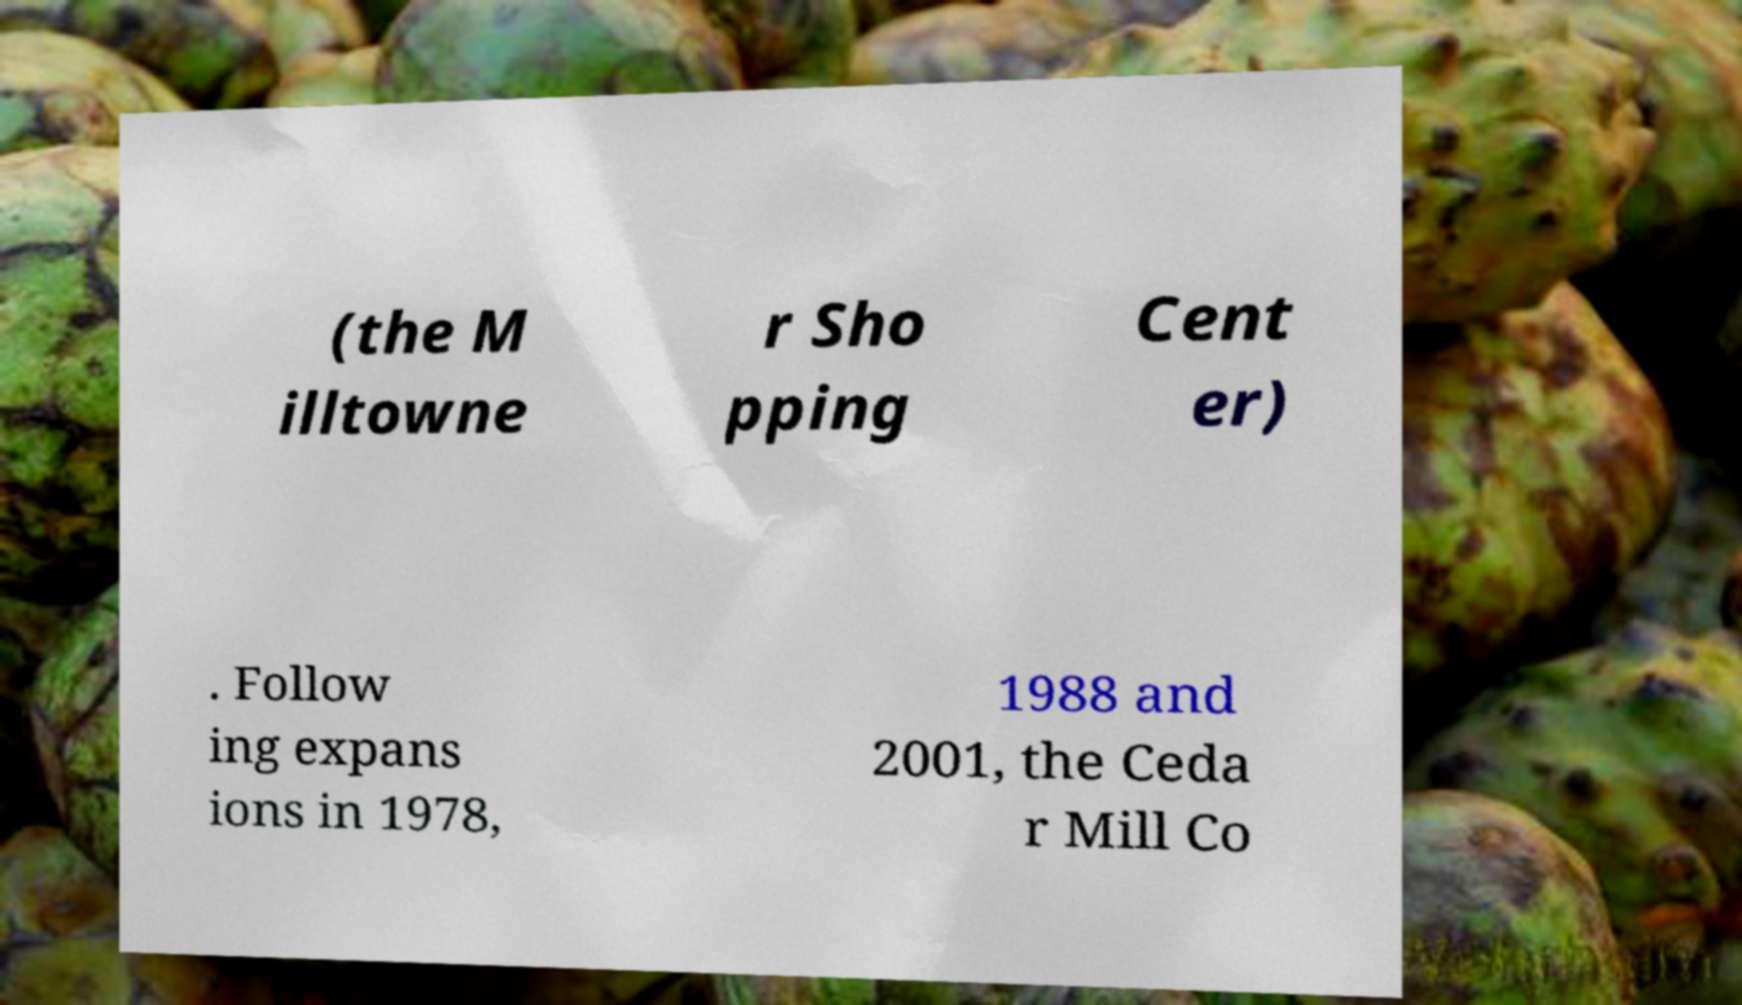For documentation purposes, I need the text within this image transcribed. Could you provide that? (the M illtowne r Sho pping Cent er) . Follow ing expans ions in 1978, 1988 and 2001, the Ceda r Mill Co 